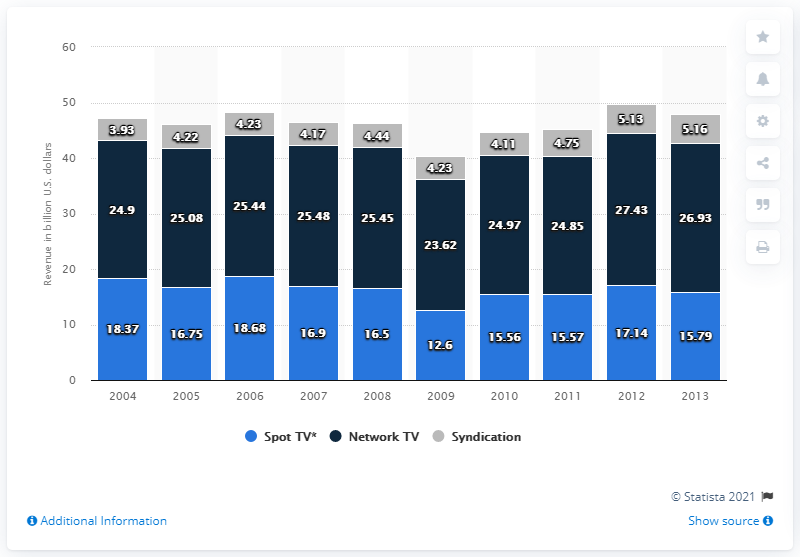Mention a couple of crucial points in this snapshot. In 2007, broadcast television generated approximately $25.45 million in ad revenue. 